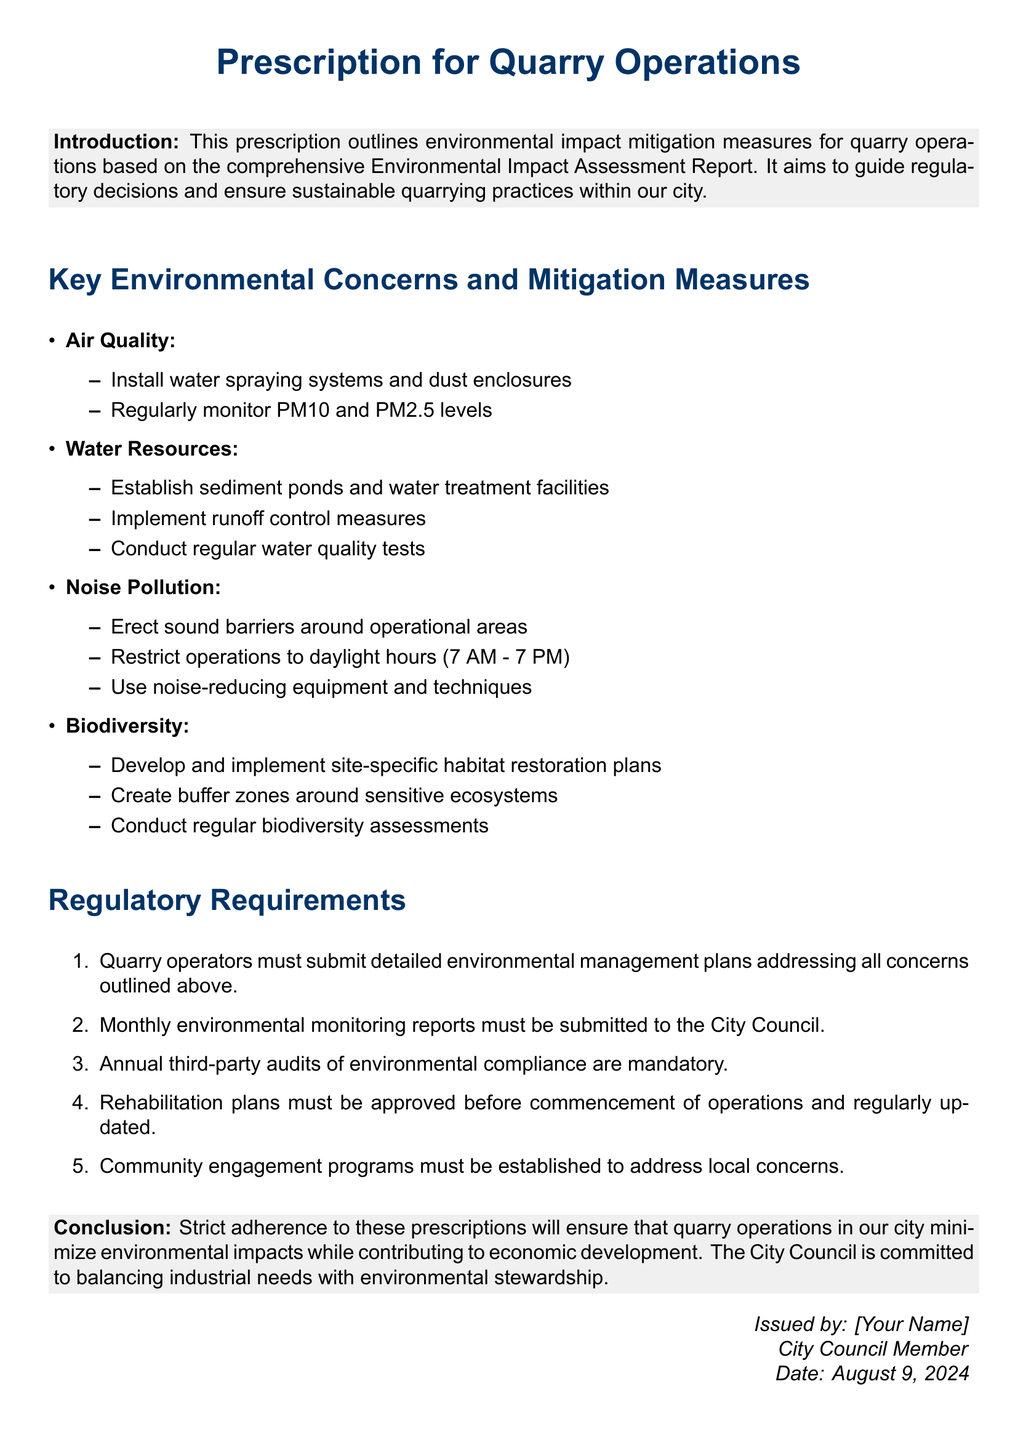What is the primary goal of the prescription? The primary goal of the prescription is to outline environmental impact mitigation measures for quarry operations.
Answer: environmental impact mitigation What time are quarry operations restricted to? The document specifies that operations are restricted to daylight hours from 7 AM to 7 PM.
Answer: 7 AM to 7 PM How often must monthly environmental monitoring reports be submitted? Quarry operators are required to submit monthly environmental monitoring reports to the City Council.
Answer: monthly What must be established to address local concerns? Community engagement programs must be established to address local concerns.
Answer: Community engagement programs What is required before the commencement of quarry operations? Rehabilitation plans must be approved before the commencement of operations.
Answer: Rehabilitation plans What type of assessments must be conducted regularly? Regular biodiversity assessments must be conducted as part of the mitigation measures.
Answer: biodiversity assessments Which environmental concern involves the installation of sound barriers? Noise pollution involves erecting sound barriers around operational areas.
Answer: Noise pollution How many key environmental concerns are listed in the document? The document lists four key environmental concerns that quarry operations must address.
Answer: four What must quarry operators submit to address potential environmental impacts? Quarry operators must submit detailed environmental management plans addressing all concerns outlined above.
Answer: environmental management plans 